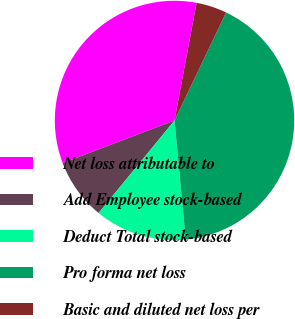Convert chart. <chart><loc_0><loc_0><loc_500><loc_500><pie_chart><fcel>Net loss attributable to<fcel>Add Employee stock-based<fcel>Deduct Total stock-based<fcel>Pro forma net loss<fcel>Basic and diluted net loss per<nl><fcel>33.74%<fcel>8.28%<fcel>12.42%<fcel>41.41%<fcel>4.14%<nl></chart> 